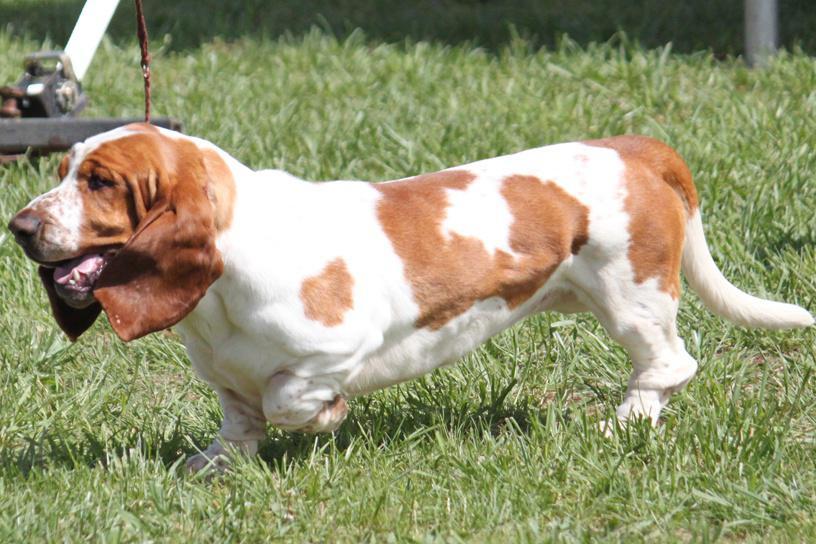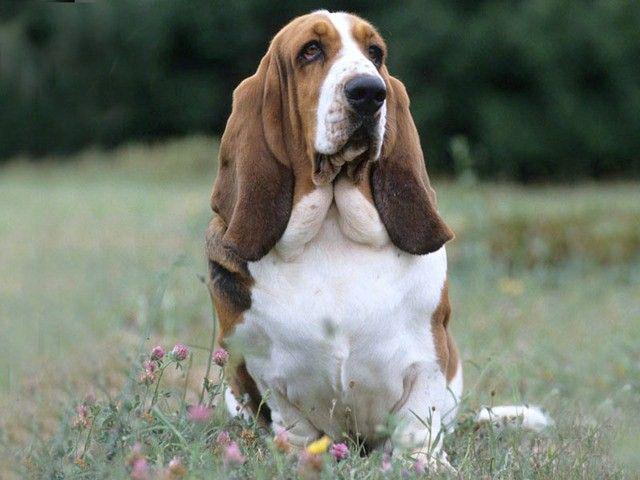The first image is the image on the left, the second image is the image on the right. For the images displayed, is the sentence "The dog in the image on the right is running toward the camera." factually correct? Answer yes or no. No. 